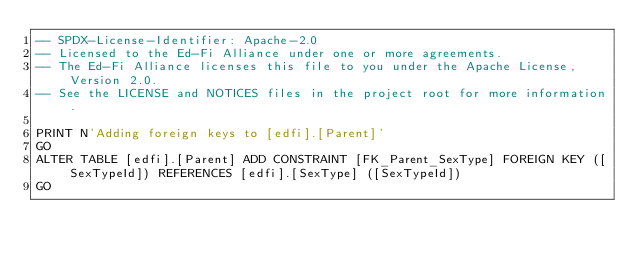Convert code to text. <code><loc_0><loc_0><loc_500><loc_500><_SQL_>-- SPDX-License-Identifier: Apache-2.0
-- Licensed to the Ed-Fi Alliance under one or more agreements.
-- The Ed-Fi Alliance licenses this file to you under the Apache License, Version 2.0.
-- See the LICENSE and NOTICES files in the project root for more information.

PRINT N'Adding foreign keys to [edfi].[Parent]'
GO
ALTER TABLE [edfi].[Parent] ADD CONSTRAINT [FK_Parent_SexType] FOREIGN KEY ([SexTypeId]) REFERENCES [edfi].[SexType] ([SexTypeId])
GO
</code> 